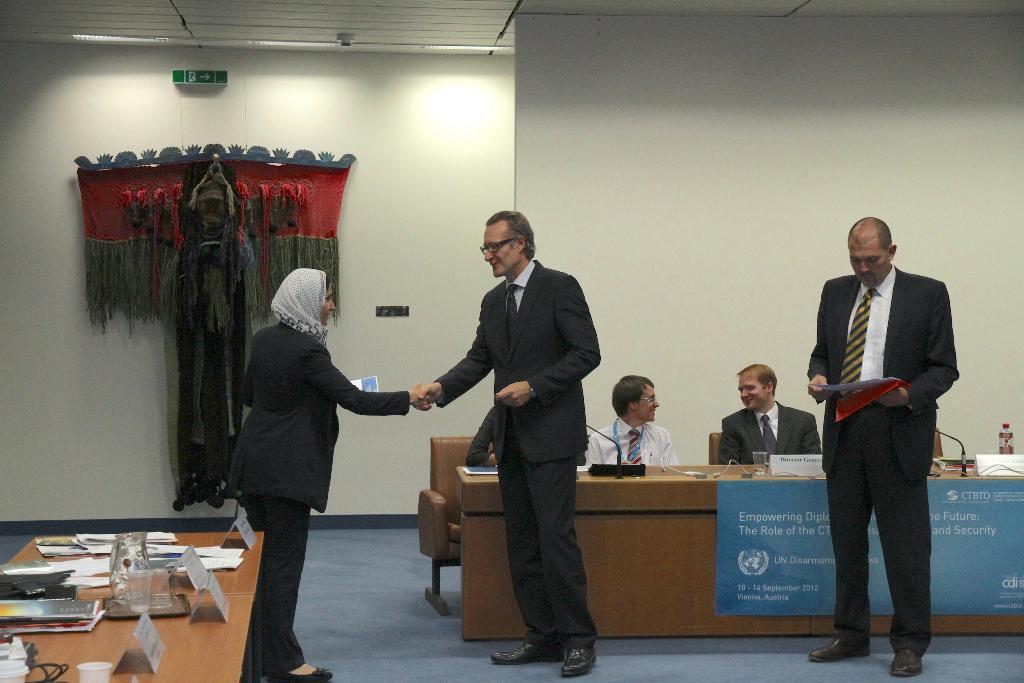In one or two sentences, can you explain what this image depicts? In this image I see a woman, who is standing over and I also see that there are 2 men standing and In the background I see 3 people sitting on the chairs. I also see that there are 2 tables and few things on it. In the background I see the wall 